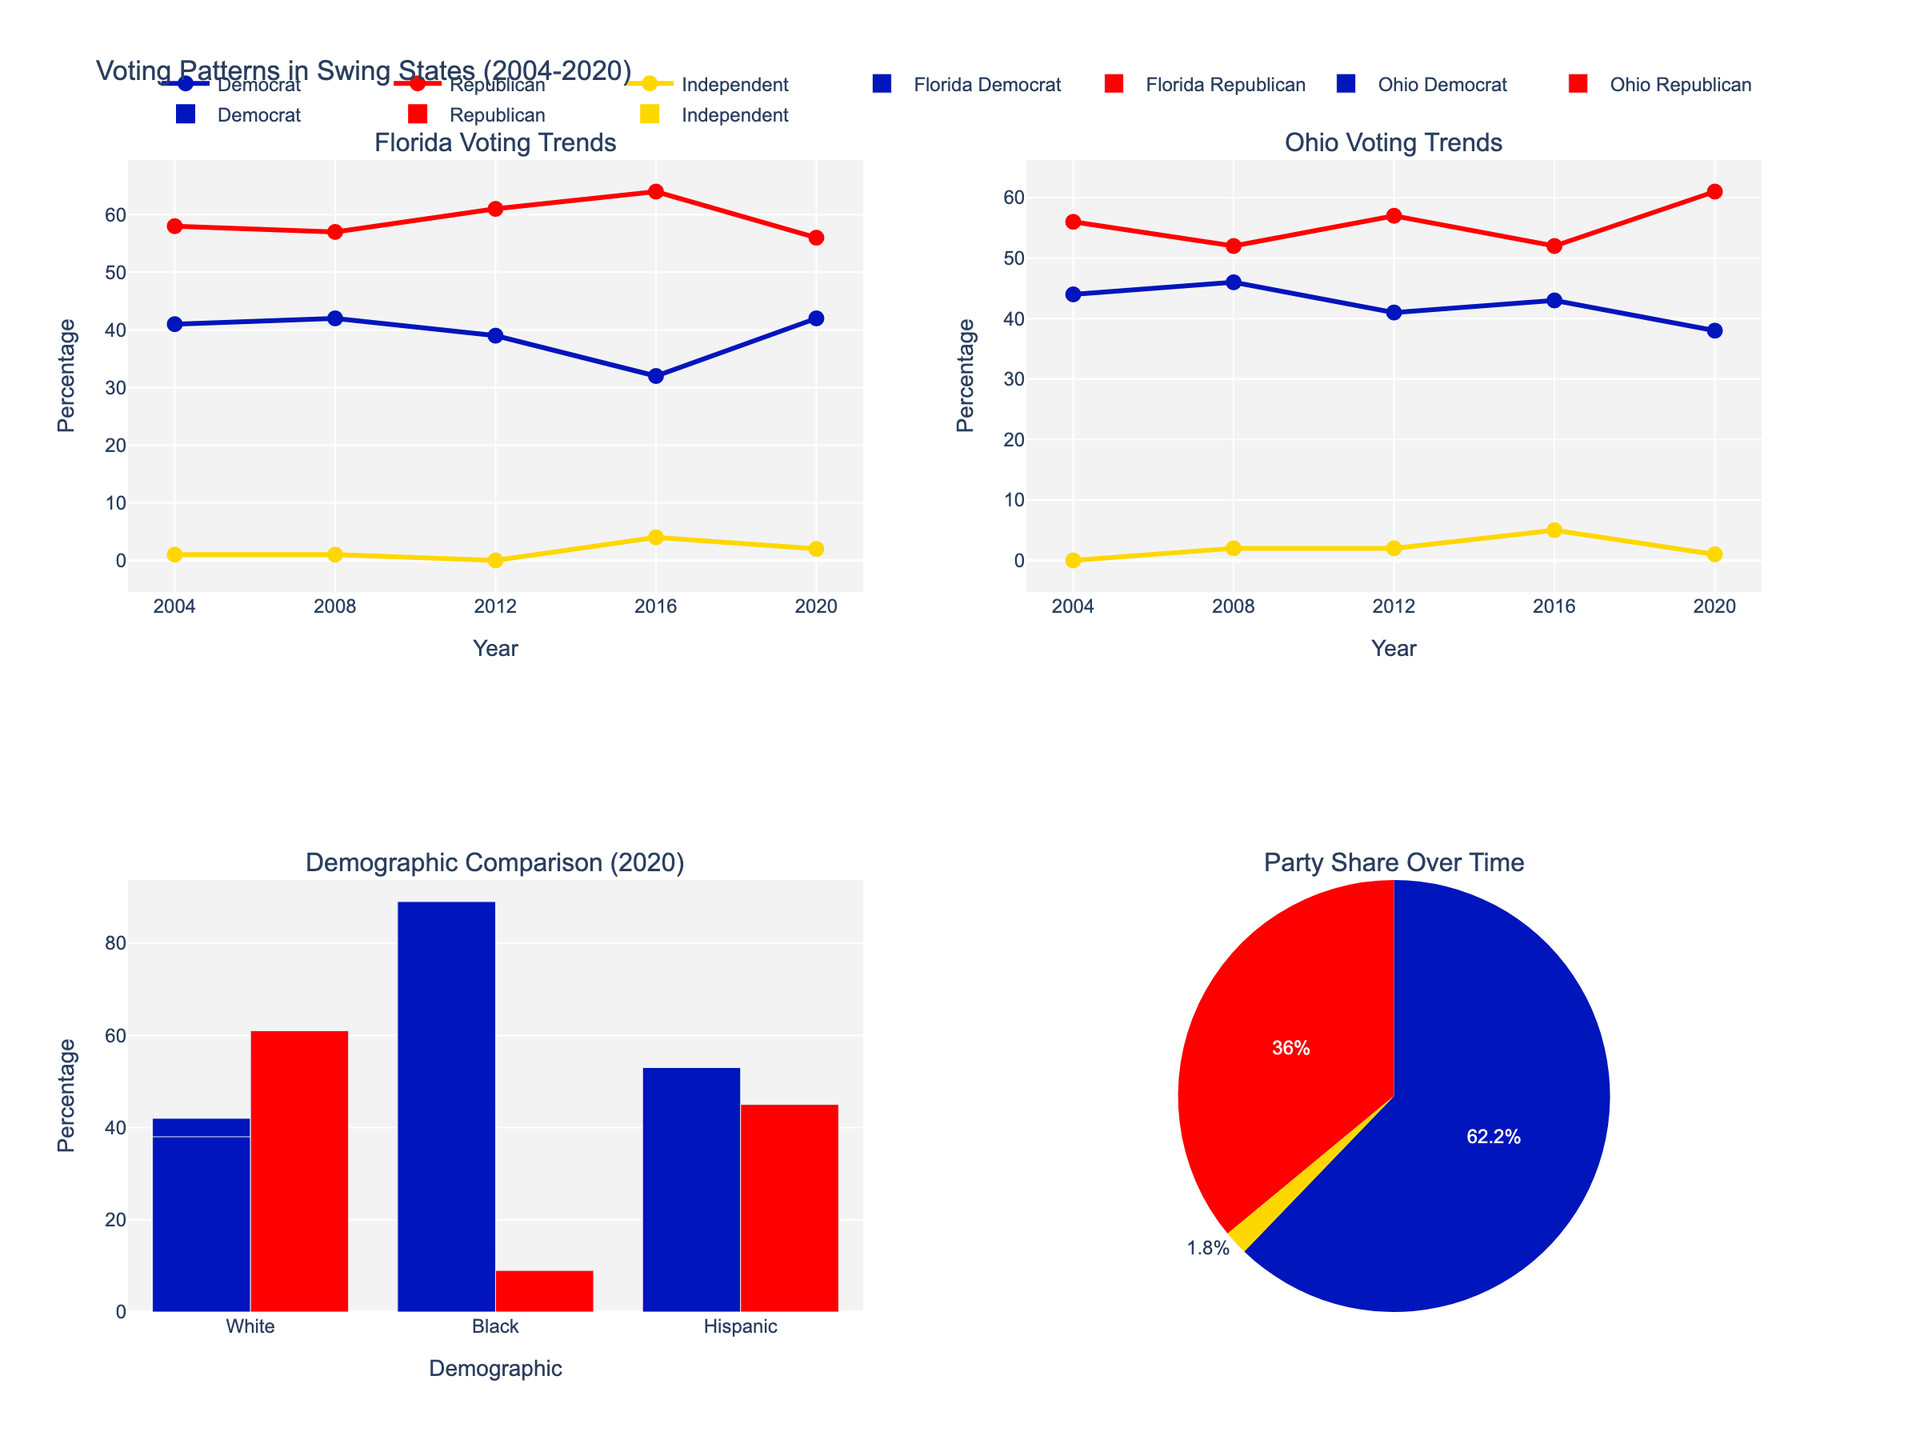Which party has the highest percentage among Whites in Florida in 2016? Looking at the subplot for Florida's voting trends, locate the year 2016 and find the values for White demographic. The plot shows Republican with 64%, Democrat with 32%, and Independent with 4%. Hence, the highest percentage is held by Republicans.
Answer: Republican Which party showed the highest support among Blacks in Ohio in 2008? Refer to the Demographic Comparison (2020) plot for the Ohio Black demographic in the year 2008. The graph indicates that Democrats held 97%, significantly higher than Republicans (2%) and Independents (1%).
Answer: Democrat What is the overall trend for Democratic support among Whites in Florida from 2004 to 2020? Check Florida's voting trends subplot; observe the line corresponding to Democrats from 2004 to 2020. There's a drop from 41% in 2004 to a low of 32% in 2016, but an increase again to 42% by 2020.
Answer: Declining until 2016, then increasing Compare the trends of Republican support among Whites in Ohio and Florida from 2004 to 2020. Examine both subplots for Ohio and Florida voting trends for the Republican lines. In Florida, Republican support decreases from 58% in 2004 to 56% in 2020. In Ohio, it fluctuates from 56% in 2004 to 61% in 2020.
Answer: Decreasing in Florida, increasing in Ohio Which demographic group in Florida had the highest percentage of Democrat support in 2020? Look at the Demographic Comparison (2020) subplot for Florida and identify the bar with the highest Democrat percentage. The Black demographic shows 89%, which is the highest among all demographics.
Answer: Black How does the percentage of Democratic votes among Hispanics in Florida change from 2008 to 2020? Check Hispanic specific bars/lines in Florida's subplot across the years 2008 (57%), 2012 (60%), 2016 (62%), and 2020 (53%). The trend initially increases each year but drops significantly in 2020.
Answer: Increased until 2016, then decreased Which party has the smallest share in the pie chart for 2020? Look at the Party Share Over Time pie chart subplot for 2020. The segment with the smallest share is the Independent party, shaded in yellow.
Answer: Independent 